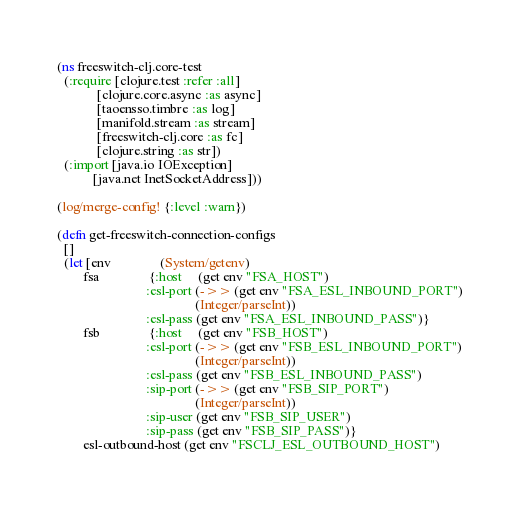<code> <loc_0><loc_0><loc_500><loc_500><_Clojure_>(ns freeswitch-clj.core-test
  (:require [clojure.test :refer :all]
            [clojure.core.async :as async]
            [taoensso.timbre :as log]
            [manifold.stream :as stream]
            [freeswitch-clj.core :as fc]
            [clojure.string :as str])
  (:import [java.io IOException]
           [java.net InetSocketAddress]))

(log/merge-config! {:level :warn})

(defn get-freeswitch-connection-configs
  []
  (let [env               (System/getenv)
        fsa               {:host     (get env "FSA_HOST")
                           :esl-port (->> (get env "FSA_ESL_INBOUND_PORT")
                                          (Integer/parseInt))
                           :esl-pass (get env "FSA_ESL_INBOUND_PASS")}
        fsb               {:host     (get env "FSB_HOST")
                           :esl-port (->> (get env "FSB_ESL_INBOUND_PORT")
                                          (Integer/parseInt))
                           :esl-pass (get env "FSB_ESL_INBOUND_PASS")
                           :sip-port (->> (get env "FSB_SIP_PORT")
                                          (Integer/parseInt))
                           :sip-user (get env "FSB_SIP_USER")
                           :sip-pass (get env "FSB_SIP_PASS")}
        esl-outbound-host (get env "FSCLJ_ESL_OUTBOUND_HOST")</code> 